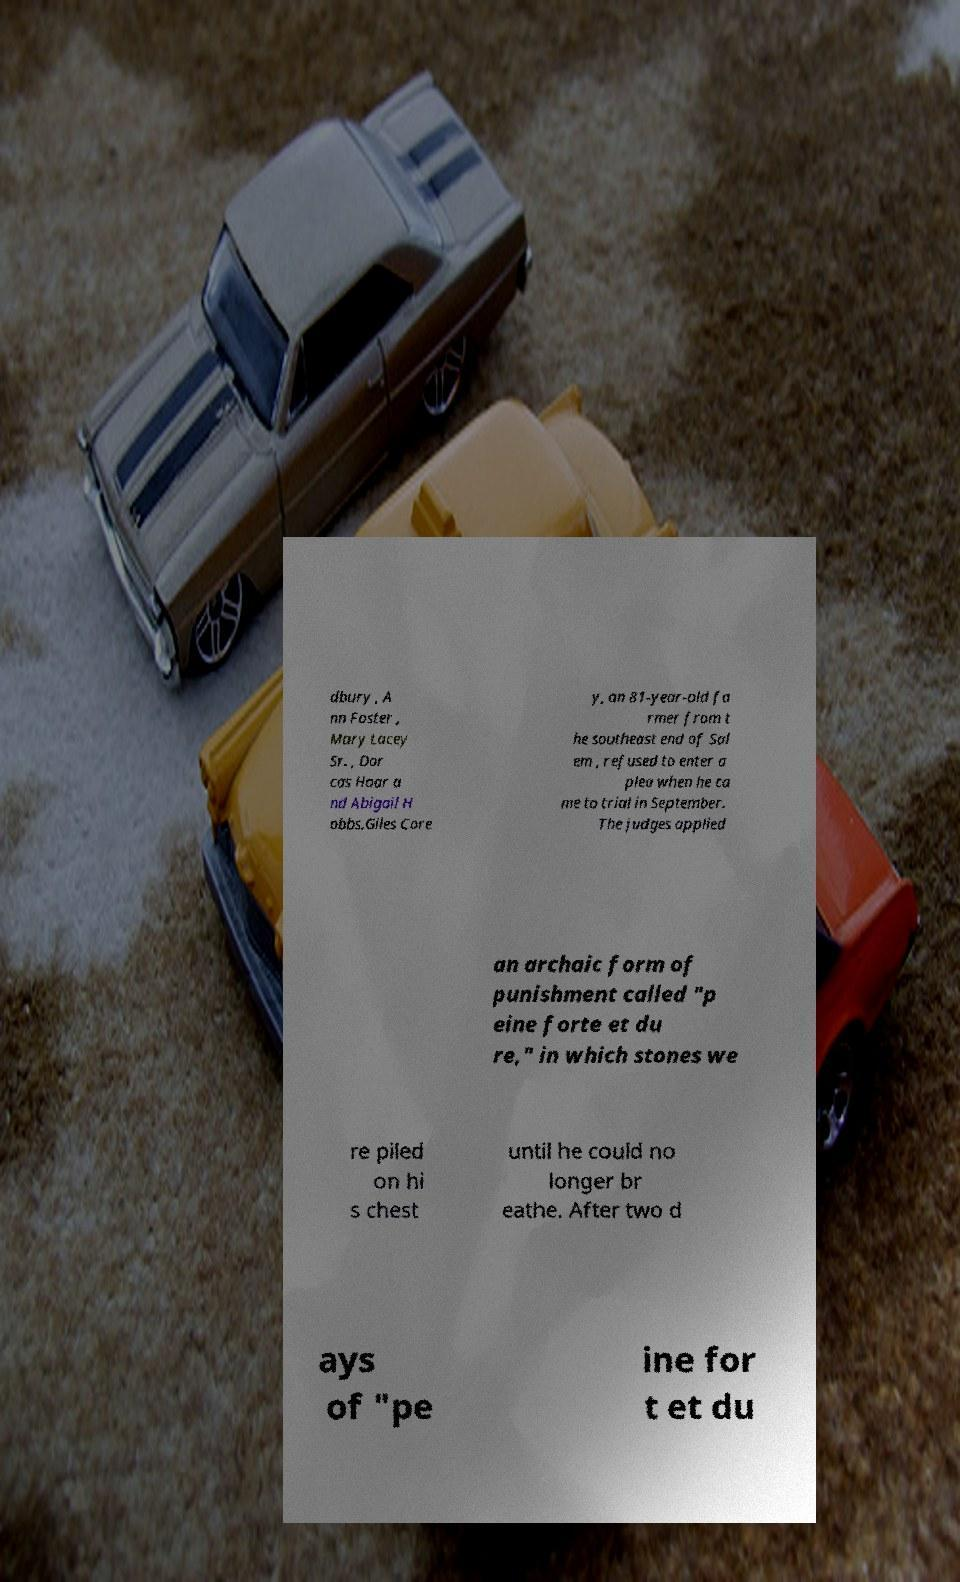Could you extract and type out the text from this image? dbury , A nn Foster , Mary Lacey Sr. , Dor cas Hoar a nd Abigail H obbs.Giles Core y, an 81-year-old fa rmer from t he southeast end of Sal em , refused to enter a plea when he ca me to trial in September. The judges applied an archaic form of punishment called "p eine forte et du re," in which stones we re piled on hi s chest until he could no longer br eathe. After two d ays of "pe ine for t et du 